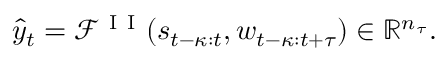Convert formula to latex. <formula><loc_0><loc_0><loc_500><loc_500>\hat { y } _ { t } = \mathcal { F } ^ { I I } ( s _ { t - \kappa \colon t } , w _ { t - \kappa \colon t + \tau } ) \in \mathbb { R } ^ { n _ { \tau } } .</formula> 